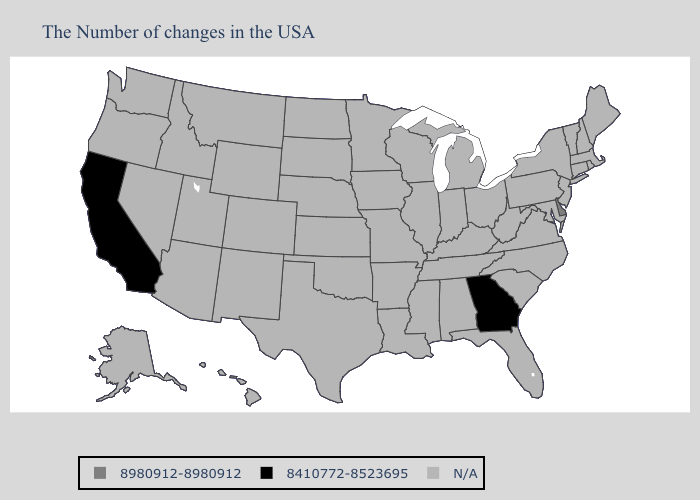What is the value of Nebraska?
Give a very brief answer. N/A. Name the states that have a value in the range N/A?
Keep it brief. Maine, Massachusetts, Rhode Island, New Hampshire, Vermont, Connecticut, New York, New Jersey, Maryland, Pennsylvania, Virginia, North Carolina, South Carolina, West Virginia, Ohio, Florida, Michigan, Kentucky, Indiana, Alabama, Tennessee, Wisconsin, Illinois, Mississippi, Louisiana, Missouri, Arkansas, Minnesota, Iowa, Kansas, Nebraska, Oklahoma, Texas, South Dakota, North Dakota, Wyoming, Colorado, New Mexico, Utah, Montana, Arizona, Idaho, Nevada, Washington, Oregon, Alaska, Hawaii. Name the states that have a value in the range 8980912-8980912?
Concise answer only. Delaware. Does Delaware have the highest value in the USA?
Concise answer only. Yes. Name the states that have a value in the range 8410772-8523695?
Concise answer only. Georgia, California. Name the states that have a value in the range 8980912-8980912?
Short answer required. Delaware. Name the states that have a value in the range 8980912-8980912?
Concise answer only. Delaware. Which states have the highest value in the USA?
Concise answer only. Delaware. Does Delaware have the highest value in the USA?
Short answer required. Yes. Which states have the highest value in the USA?
Keep it brief. Delaware. What is the highest value in the USA?
Give a very brief answer. 8980912-8980912. Does Georgia have the highest value in the South?
Quick response, please. No. 